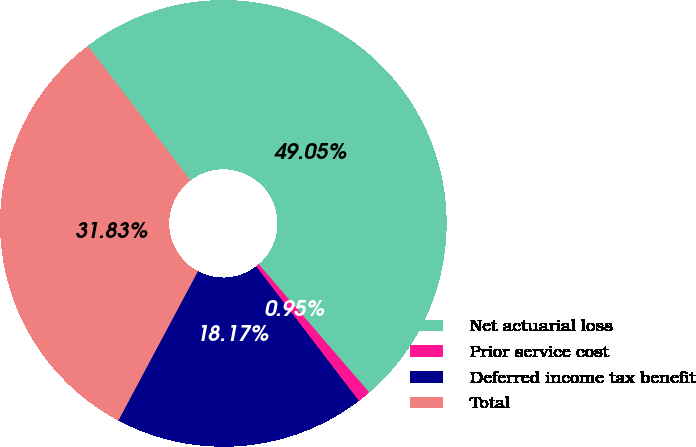Convert chart. <chart><loc_0><loc_0><loc_500><loc_500><pie_chart><fcel>Net actuarial loss<fcel>Prior service cost<fcel>Deferred income tax benefit<fcel>Total<nl><fcel>49.05%<fcel>0.95%<fcel>18.17%<fcel>31.83%<nl></chart> 